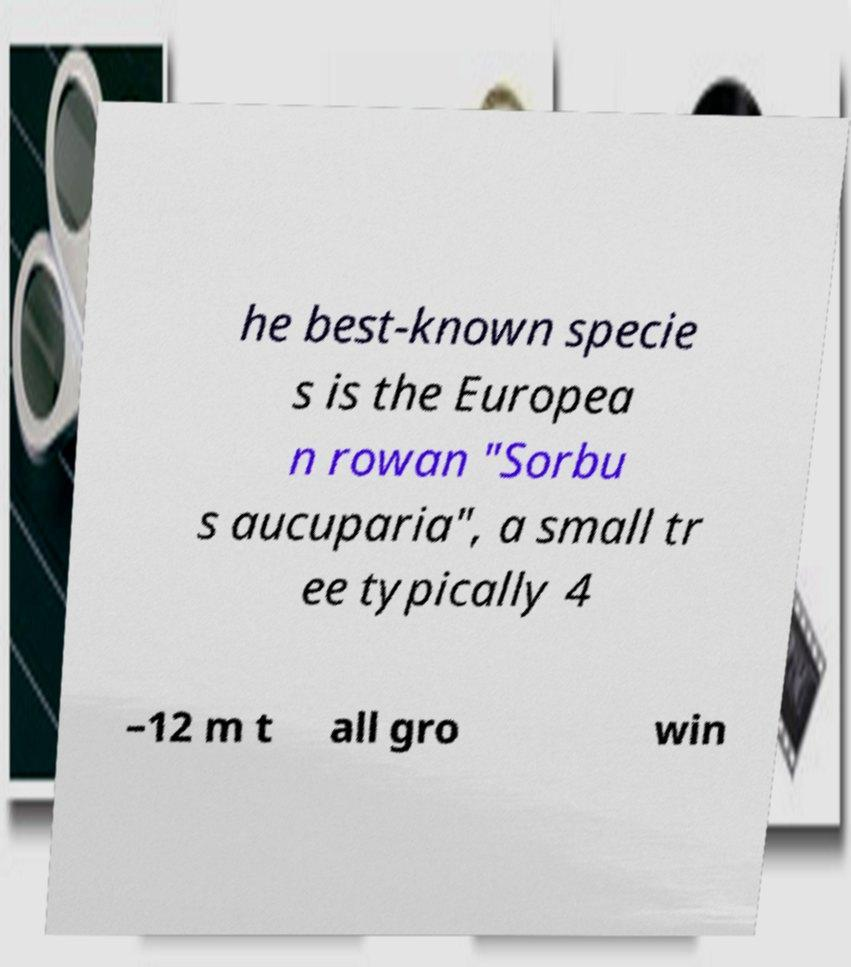Can you read and provide the text displayed in the image?This photo seems to have some interesting text. Can you extract and type it out for me? he best-known specie s is the Europea n rowan "Sorbu s aucuparia", a small tr ee typically 4 –12 m t all gro win 